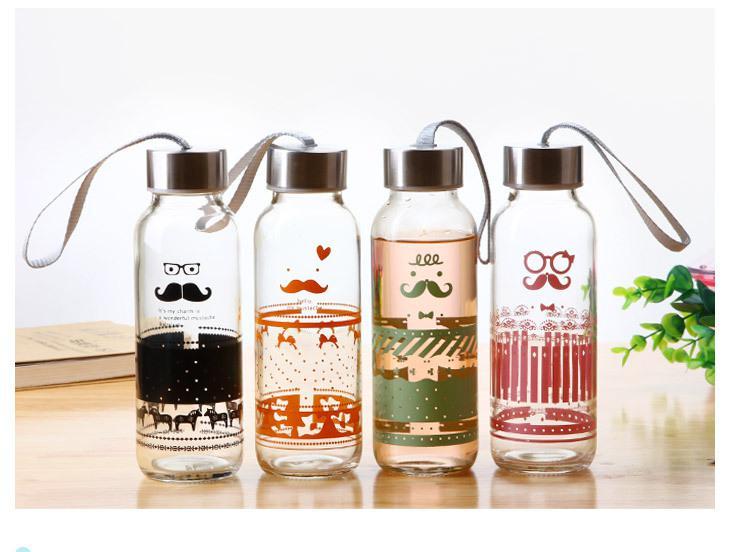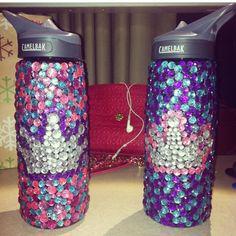The first image is the image on the left, the second image is the image on the right. For the images displayed, is the sentence "One image features a horizontal row of four water bottles with straps on them and different designs on their fronts." factually correct? Answer yes or no. Yes. The first image is the image on the left, the second image is the image on the right. Given the left and right images, does the statement "In one of the images, four water bottles with carrying straps are sitting in a row on a table." hold true? Answer yes or no. Yes. 